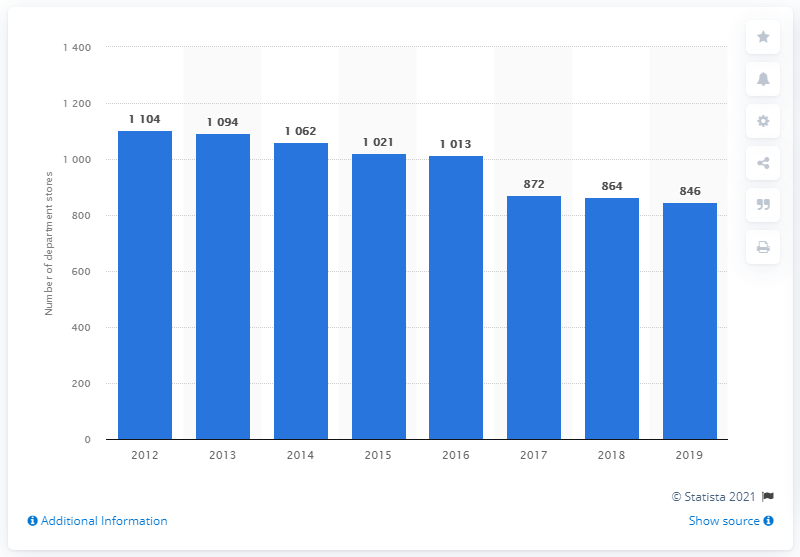Highlight a few significant elements in this photo. In 2019, J.C. Penney operated a total of 846 department stores across the United States. 